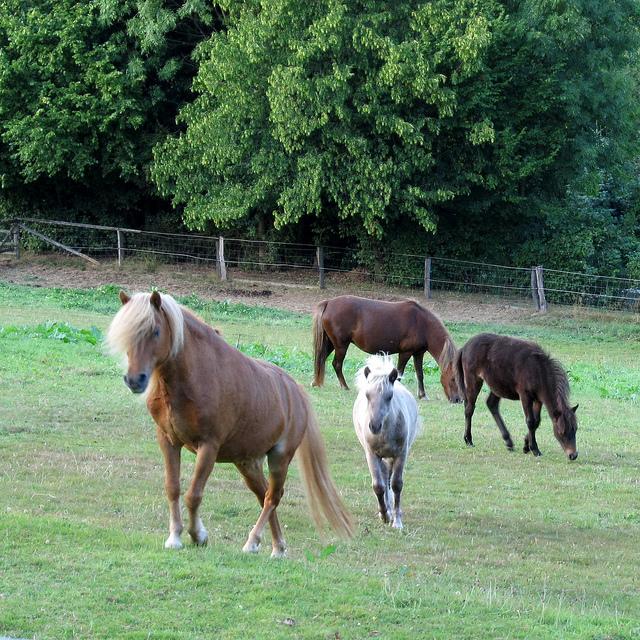How many horses are eating?
Be succinct. 2. What are these baby animals called?
Concise answer only. Horses. Is this a pasture?
Be succinct. Yes. Are the horses close in?
Keep it brief. Yes. How many horses are there?
Concise answer only. 4. What are these animals?
Be succinct. Horses. 